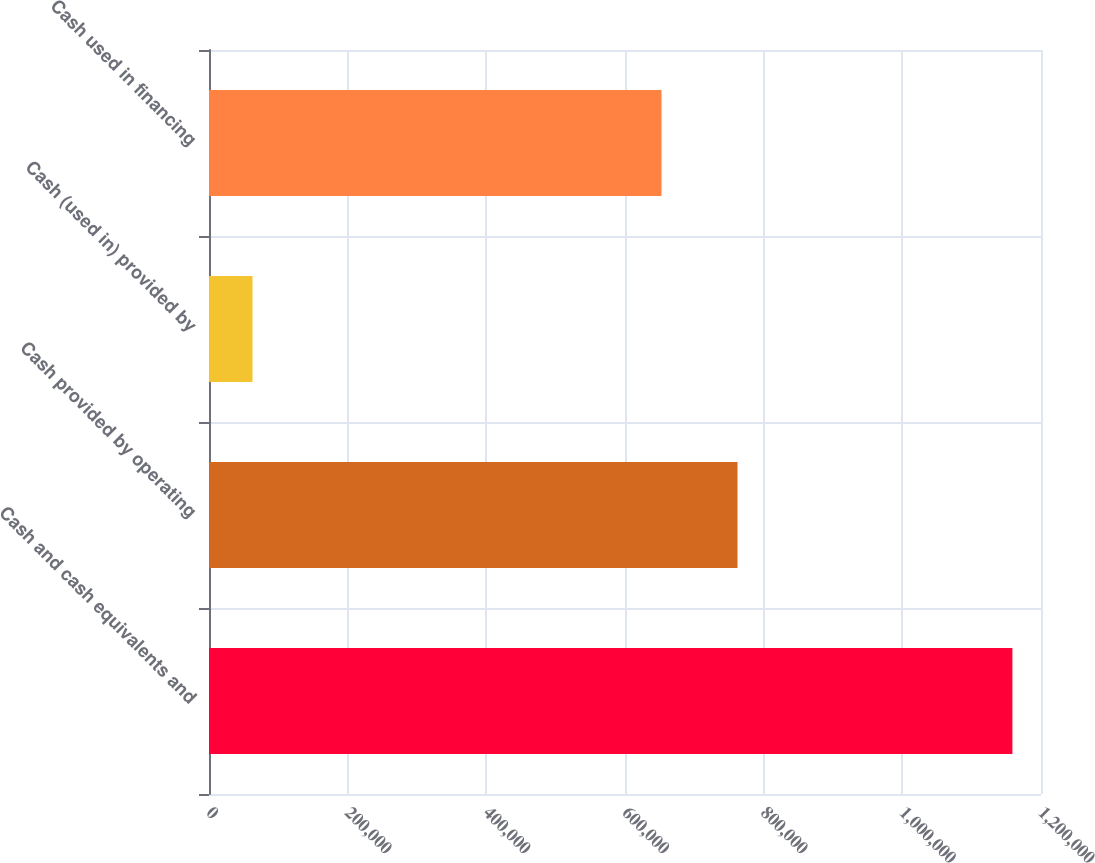Convert chart. <chart><loc_0><loc_0><loc_500><loc_500><bar_chart><fcel>Cash and cash equivalents and<fcel>Cash provided by operating<fcel>Cash (used in) provided by<fcel>Cash used in financing<nl><fcel>1.15877e+06<fcel>762252<fcel>62720<fcel>652647<nl></chart> 